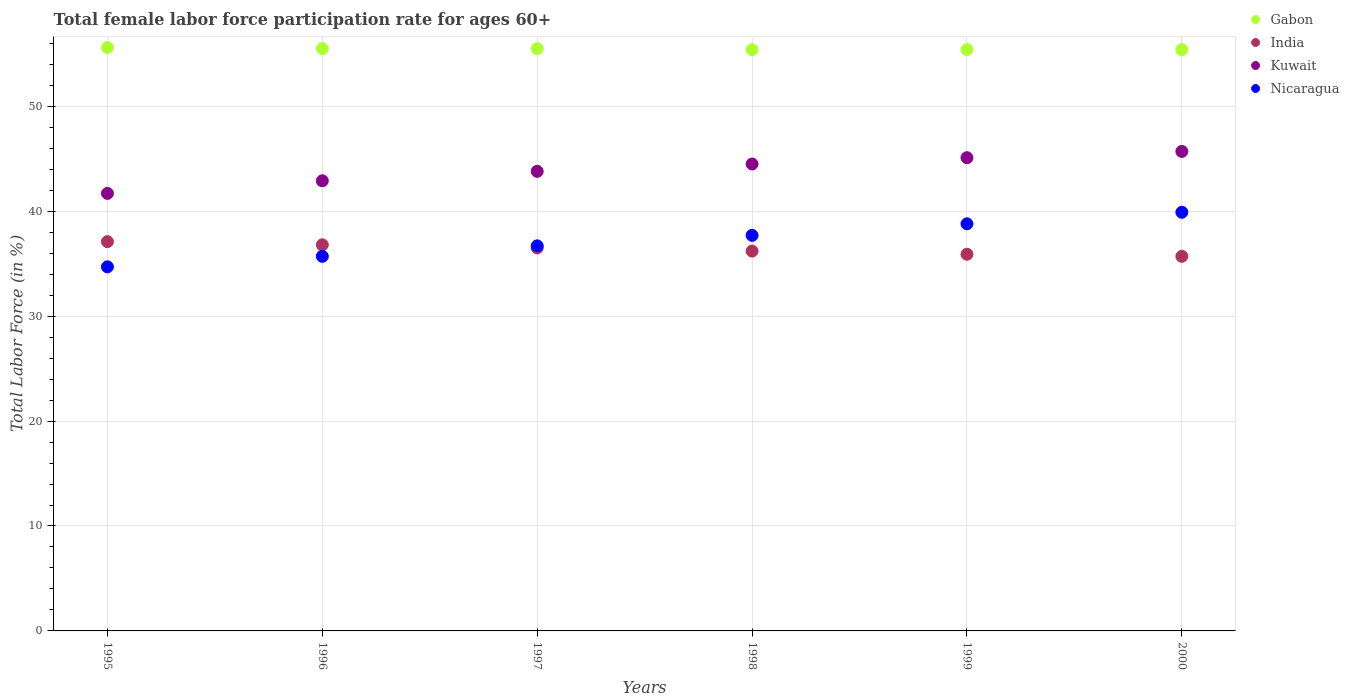How many different coloured dotlines are there?
Make the answer very short. 4. What is the female labor force participation rate in Gabon in 2000?
Your response must be concise. 55.4. Across all years, what is the maximum female labor force participation rate in Kuwait?
Offer a terse response. 45.7. Across all years, what is the minimum female labor force participation rate in Nicaragua?
Give a very brief answer. 34.7. In which year was the female labor force participation rate in Nicaragua minimum?
Make the answer very short. 1995. What is the total female labor force participation rate in Kuwait in the graph?
Offer a terse response. 263.7. What is the difference between the female labor force participation rate in Nicaragua in 1996 and that in 1998?
Offer a terse response. -2. What is the average female labor force participation rate in Kuwait per year?
Give a very brief answer. 43.95. In how many years, is the female labor force participation rate in Nicaragua greater than 20 %?
Your response must be concise. 6. What is the ratio of the female labor force participation rate in Nicaragua in 1995 to that in 1997?
Offer a terse response. 0.95. Is the female labor force participation rate in India in 1995 less than that in 1996?
Make the answer very short. No. Is the difference between the female labor force participation rate in Gabon in 1997 and 2000 greater than the difference between the female labor force participation rate in Nicaragua in 1997 and 2000?
Make the answer very short. Yes. What is the difference between the highest and the second highest female labor force participation rate in Kuwait?
Offer a terse response. 0.6. What is the difference between the highest and the lowest female labor force participation rate in Gabon?
Provide a short and direct response. 0.2. In how many years, is the female labor force participation rate in Kuwait greater than the average female labor force participation rate in Kuwait taken over all years?
Make the answer very short. 3. Is the sum of the female labor force participation rate in Kuwait in 1995 and 1997 greater than the maximum female labor force participation rate in Nicaragua across all years?
Keep it short and to the point. Yes. Is it the case that in every year, the sum of the female labor force participation rate in Kuwait and female labor force participation rate in Nicaragua  is greater than the sum of female labor force participation rate in India and female labor force participation rate in Gabon?
Your answer should be very brief. No. Is the female labor force participation rate in Gabon strictly less than the female labor force participation rate in Kuwait over the years?
Your response must be concise. No. How many years are there in the graph?
Offer a terse response. 6. Are the values on the major ticks of Y-axis written in scientific E-notation?
Your answer should be very brief. No. Does the graph contain any zero values?
Make the answer very short. No. Does the graph contain grids?
Provide a succinct answer. Yes. Where does the legend appear in the graph?
Keep it short and to the point. Top right. How many legend labels are there?
Keep it short and to the point. 4. How are the legend labels stacked?
Ensure brevity in your answer.  Vertical. What is the title of the graph?
Ensure brevity in your answer.  Total female labor force participation rate for ages 60+. What is the label or title of the X-axis?
Offer a very short reply. Years. What is the label or title of the Y-axis?
Ensure brevity in your answer.  Total Labor Force (in %). What is the Total Labor Force (in %) of Gabon in 1995?
Your answer should be compact. 55.6. What is the Total Labor Force (in %) in India in 1995?
Keep it short and to the point. 37.1. What is the Total Labor Force (in %) in Kuwait in 1995?
Offer a very short reply. 41.7. What is the Total Labor Force (in %) in Nicaragua in 1995?
Provide a short and direct response. 34.7. What is the Total Labor Force (in %) of Gabon in 1996?
Your response must be concise. 55.5. What is the Total Labor Force (in %) of India in 1996?
Give a very brief answer. 36.8. What is the Total Labor Force (in %) in Kuwait in 1996?
Offer a terse response. 42.9. What is the Total Labor Force (in %) of Nicaragua in 1996?
Make the answer very short. 35.7. What is the Total Labor Force (in %) in Gabon in 1997?
Your answer should be compact. 55.5. What is the Total Labor Force (in %) in India in 1997?
Provide a short and direct response. 36.5. What is the Total Labor Force (in %) of Kuwait in 1997?
Provide a short and direct response. 43.8. What is the Total Labor Force (in %) of Nicaragua in 1997?
Ensure brevity in your answer.  36.7. What is the Total Labor Force (in %) in Gabon in 1998?
Keep it short and to the point. 55.4. What is the Total Labor Force (in %) of India in 1998?
Make the answer very short. 36.2. What is the Total Labor Force (in %) of Kuwait in 1998?
Offer a terse response. 44.5. What is the Total Labor Force (in %) of Nicaragua in 1998?
Offer a very short reply. 37.7. What is the Total Labor Force (in %) of Gabon in 1999?
Offer a very short reply. 55.4. What is the Total Labor Force (in %) of India in 1999?
Ensure brevity in your answer.  35.9. What is the Total Labor Force (in %) of Kuwait in 1999?
Make the answer very short. 45.1. What is the Total Labor Force (in %) in Nicaragua in 1999?
Your response must be concise. 38.8. What is the Total Labor Force (in %) of Gabon in 2000?
Provide a short and direct response. 55.4. What is the Total Labor Force (in %) of India in 2000?
Your answer should be compact. 35.7. What is the Total Labor Force (in %) in Kuwait in 2000?
Ensure brevity in your answer.  45.7. What is the Total Labor Force (in %) in Nicaragua in 2000?
Provide a succinct answer. 39.9. Across all years, what is the maximum Total Labor Force (in %) of Gabon?
Offer a terse response. 55.6. Across all years, what is the maximum Total Labor Force (in %) in India?
Give a very brief answer. 37.1. Across all years, what is the maximum Total Labor Force (in %) of Kuwait?
Provide a succinct answer. 45.7. Across all years, what is the maximum Total Labor Force (in %) in Nicaragua?
Make the answer very short. 39.9. Across all years, what is the minimum Total Labor Force (in %) in Gabon?
Make the answer very short. 55.4. Across all years, what is the minimum Total Labor Force (in %) in India?
Ensure brevity in your answer.  35.7. Across all years, what is the minimum Total Labor Force (in %) of Kuwait?
Keep it short and to the point. 41.7. Across all years, what is the minimum Total Labor Force (in %) of Nicaragua?
Your response must be concise. 34.7. What is the total Total Labor Force (in %) of Gabon in the graph?
Provide a succinct answer. 332.8. What is the total Total Labor Force (in %) of India in the graph?
Your response must be concise. 218.2. What is the total Total Labor Force (in %) in Kuwait in the graph?
Offer a very short reply. 263.7. What is the total Total Labor Force (in %) of Nicaragua in the graph?
Provide a short and direct response. 223.5. What is the difference between the Total Labor Force (in %) of Kuwait in 1995 and that in 1996?
Provide a short and direct response. -1.2. What is the difference between the Total Labor Force (in %) of Gabon in 1995 and that in 1997?
Ensure brevity in your answer.  0.1. What is the difference between the Total Labor Force (in %) in Kuwait in 1995 and that in 1998?
Keep it short and to the point. -2.8. What is the difference between the Total Labor Force (in %) in Nicaragua in 1995 and that in 1998?
Offer a very short reply. -3. What is the difference between the Total Labor Force (in %) in India in 1995 and that in 2000?
Ensure brevity in your answer.  1.4. What is the difference between the Total Labor Force (in %) in Gabon in 1996 and that in 1997?
Ensure brevity in your answer.  0. What is the difference between the Total Labor Force (in %) of Kuwait in 1996 and that in 1997?
Provide a short and direct response. -0.9. What is the difference between the Total Labor Force (in %) of Nicaragua in 1996 and that in 1997?
Give a very brief answer. -1. What is the difference between the Total Labor Force (in %) of India in 1996 and that in 1998?
Your answer should be very brief. 0.6. What is the difference between the Total Labor Force (in %) of Nicaragua in 1996 and that in 1999?
Ensure brevity in your answer.  -3.1. What is the difference between the Total Labor Force (in %) in Gabon in 1996 and that in 2000?
Make the answer very short. 0.1. What is the difference between the Total Labor Force (in %) in Kuwait in 1996 and that in 2000?
Provide a succinct answer. -2.8. What is the difference between the Total Labor Force (in %) of Nicaragua in 1996 and that in 2000?
Give a very brief answer. -4.2. What is the difference between the Total Labor Force (in %) of Gabon in 1997 and that in 1998?
Provide a short and direct response. 0.1. What is the difference between the Total Labor Force (in %) in India in 1997 and that in 1998?
Provide a short and direct response. 0.3. What is the difference between the Total Labor Force (in %) in Nicaragua in 1997 and that in 1998?
Give a very brief answer. -1. What is the difference between the Total Labor Force (in %) in India in 1997 and that in 1999?
Make the answer very short. 0.6. What is the difference between the Total Labor Force (in %) of Kuwait in 1997 and that in 1999?
Offer a very short reply. -1.3. What is the difference between the Total Labor Force (in %) in Nicaragua in 1997 and that in 1999?
Your answer should be compact. -2.1. What is the difference between the Total Labor Force (in %) of Gabon in 1997 and that in 2000?
Make the answer very short. 0.1. What is the difference between the Total Labor Force (in %) of India in 1997 and that in 2000?
Offer a very short reply. 0.8. What is the difference between the Total Labor Force (in %) in Gabon in 1998 and that in 1999?
Provide a succinct answer. 0. What is the difference between the Total Labor Force (in %) in Kuwait in 1998 and that in 1999?
Offer a terse response. -0.6. What is the difference between the Total Labor Force (in %) of India in 1998 and that in 2000?
Your answer should be compact. 0.5. What is the difference between the Total Labor Force (in %) of Gabon in 1999 and that in 2000?
Offer a very short reply. 0. What is the difference between the Total Labor Force (in %) of Nicaragua in 1999 and that in 2000?
Your answer should be compact. -1.1. What is the difference between the Total Labor Force (in %) in Gabon in 1995 and the Total Labor Force (in %) in India in 1996?
Give a very brief answer. 18.8. What is the difference between the Total Labor Force (in %) of Gabon in 1995 and the Total Labor Force (in %) of Kuwait in 1996?
Give a very brief answer. 12.7. What is the difference between the Total Labor Force (in %) in Gabon in 1995 and the Total Labor Force (in %) in Nicaragua in 1996?
Offer a terse response. 19.9. What is the difference between the Total Labor Force (in %) in Gabon in 1995 and the Total Labor Force (in %) in India in 1997?
Your answer should be very brief. 19.1. What is the difference between the Total Labor Force (in %) in Gabon in 1995 and the Total Labor Force (in %) in Kuwait in 1997?
Make the answer very short. 11.8. What is the difference between the Total Labor Force (in %) in India in 1995 and the Total Labor Force (in %) in Kuwait in 1997?
Your answer should be very brief. -6.7. What is the difference between the Total Labor Force (in %) of India in 1995 and the Total Labor Force (in %) of Nicaragua in 1997?
Make the answer very short. 0.4. What is the difference between the Total Labor Force (in %) of Gabon in 1995 and the Total Labor Force (in %) of India in 1998?
Your response must be concise. 19.4. What is the difference between the Total Labor Force (in %) in Gabon in 1995 and the Total Labor Force (in %) in Nicaragua in 1998?
Your response must be concise. 17.9. What is the difference between the Total Labor Force (in %) in India in 1995 and the Total Labor Force (in %) in Nicaragua in 1998?
Your response must be concise. -0.6. What is the difference between the Total Labor Force (in %) in Gabon in 1995 and the Total Labor Force (in %) in India in 1999?
Keep it short and to the point. 19.7. What is the difference between the Total Labor Force (in %) of Gabon in 1995 and the Total Labor Force (in %) of Nicaragua in 1999?
Ensure brevity in your answer.  16.8. What is the difference between the Total Labor Force (in %) of India in 1995 and the Total Labor Force (in %) of Kuwait in 1999?
Your response must be concise. -8. What is the difference between the Total Labor Force (in %) of Kuwait in 1995 and the Total Labor Force (in %) of Nicaragua in 1999?
Ensure brevity in your answer.  2.9. What is the difference between the Total Labor Force (in %) in Gabon in 1995 and the Total Labor Force (in %) in India in 2000?
Your answer should be compact. 19.9. What is the difference between the Total Labor Force (in %) of Gabon in 1995 and the Total Labor Force (in %) of Kuwait in 2000?
Provide a succinct answer. 9.9. What is the difference between the Total Labor Force (in %) of Gabon in 1996 and the Total Labor Force (in %) of Kuwait in 1997?
Keep it short and to the point. 11.7. What is the difference between the Total Labor Force (in %) of India in 1996 and the Total Labor Force (in %) of Kuwait in 1997?
Your answer should be very brief. -7. What is the difference between the Total Labor Force (in %) in Kuwait in 1996 and the Total Labor Force (in %) in Nicaragua in 1997?
Give a very brief answer. 6.2. What is the difference between the Total Labor Force (in %) in Gabon in 1996 and the Total Labor Force (in %) in India in 1998?
Your answer should be compact. 19.3. What is the difference between the Total Labor Force (in %) of Gabon in 1996 and the Total Labor Force (in %) of Kuwait in 1998?
Make the answer very short. 11. What is the difference between the Total Labor Force (in %) in Gabon in 1996 and the Total Labor Force (in %) in Nicaragua in 1998?
Provide a short and direct response. 17.8. What is the difference between the Total Labor Force (in %) in India in 1996 and the Total Labor Force (in %) in Kuwait in 1998?
Your response must be concise. -7.7. What is the difference between the Total Labor Force (in %) of India in 1996 and the Total Labor Force (in %) of Nicaragua in 1998?
Ensure brevity in your answer.  -0.9. What is the difference between the Total Labor Force (in %) in Gabon in 1996 and the Total Labor Force (in %) in India in 1999?
Keep it short and to the point. 19.6. What is the difference between the Total Labor Force (in %) in Gabon in 1996 and the Total Labor Force (in %) in Nicaragua in 1999?
Give a very brief answer. 16.7. What is the difference between the Total Labor Force (in %) of India in 1996 and the Total Labor Force (in %) of Nicaragua in 1999?
Your answer should be compact. -2. What is the difference between the Total Labor Force (in %) in Kuwait in 1996 and the Total Labor Force (in %) in Nicaragua in 1999?
Keep it short and to the point. 4.1. What is the difference between the Total Labor Force (in %) of Gabon in 1996 and the Total Labor Force (in %) of India in 2000?
Give a very brief answer. 19.8. What is the difference between the Total Labor Force (in %) in Gabon in 1996 and the Total Labor Force (in %) in Kuwait in 2000?
Give a very brief answer. 9.8. What is the difference between the Total Labor Force (in %) in India in 1996 and the Total Labor Force (in %) in Nicaragua in 2000?
Provide a succinct answer. -3.1. What is the difference between the Total Labor Force (in %) of Gabon in 1997 and the Total Labor Force (in %) of India in 1998?
Give a very brief answer. 19.3. What is the difference between the Total Labor Force (in %) in Gabon in 1997 and the Total Labor Force (in %) in Nicaragua in 1998?
Your answer should be very brief. 17.8. What is the difference between the Total Labor Force (in %) in India in 1997 and the Total Labor Force (in %) in Kuwait in 1998?
Your answer should be very brief. -8. What is the difference between the Total Labor Force (in %) in Kuwait in 1997 and the Total Labor Force (in %) in Nicaragua in 1998?
Make the answer very short. 6.1. What is the difference between the Total Labor Force (in %) of Gabon in 1997 and the Total Labor Force (in %) of India in 1999?
Keep it short and to the point. 19.6. What is the difference between the Total Labor Force (in %) of Gabon in 1997 and the Total Labor Force (in %) of Nicaragua in 1999?
Your answer should be very brief. 16.7. What is the difference between the Total Labor Force (in %) of India in 1997 and the Total Labor Force (in %) of Nicaragua in 1999?
Offer a terse response. -2.3. What is the difference between the Total Labor Force (in %) of Gabon in 1997 and the Total Labor Force (in %) of India in 2000?
Offer a very short reply. 19.8. What is the difference between the Total Labor Force (in %) of Gabon in 1997 and the Total Labor Force (in %) of Kuwait in 2000?
Give a very brief answer. 9.8. What is the difference between the Total Labor Force (in %) in India in 1997 and the Total Labor Force (in %) in Kuwait in 2000?
Keep it short and to the point. -9.2. What is the difference between the Total Labor Force (in %) in India in 1997 and the Total Labor Force (in %) in Nicaragua in 2000?
Ensure brevity in your answer.  -3.4. What is the difference between the Total Labor Force (in %) in Gabon in 1998 and the Total Labor Force (in %) in Kuwait in 1999?
Your answer should be compact. 10.3. What is the difference between the Total Labor Force (in %) in Gabon in 1998 and the Total Labor Force (in %) in Nicaragua in 1999?
Offer a terse response. 16.6. What is the difference between the Total Labor Force (in %) of India in 1998 and the Total Labor Force (in %) of Kuwait in 1999?
Keep it short and to the point. -8.9. What is the difference between the Total Labor Force (in %) of India in 1998 and the Total Labor Force (in %) of Nicaragua in 1999?
Make the answer very short. -2.6. What is the difference between the Total Labor Force (in %) in Gabon in 1998 and the Total Labor Force (in %) in Kuwait in 2000?
Ensure brevity in your answer.  9.7. What is the difference between the Total Labor Force (in %) in Gabon in 1998 and the Total Labor Force (in %) in Nicaragua in 2000?
Offer a very short reply. 15.5. What is the difference between the Total Labor Force (in %) of Gabon in 1999 and the Total Labor Force (in %) of Nicaragua in 2000?
Keep it short and to the point. 15.5. What is the difference between the Total Labor Force (in %) in India in 1999 and the Total Labor Force (in %) in Kuwait in 2000?
Offer a terse response. -9.8. What is the average Total Labor Force (in %) of Gabon per year?
Offer a very short reply. 55.47. What is the average Total Labor Force (in %) of India per year?
Your response must be concise. 36.37. What is the average Total Labor Force (in %) of Kuwait per year?
Your answer should be compact. 43.95. What is the average Total Labor Force (in %) of Nicaragua per year?
Make the answer very short. 37.25. In the year 1995, what is the difference between the Total Labor Force (in %) in Gabon and Total Labor Force (in %) in India?
Keep it short and to the point. 18.5. In the year 1995, what is the difference between the Total Labor Force (in %) of Gabon and Total Labor Force (in %) of Kuwait?
Make the answer very short. 13.9. In the year 1995, what is the difference between the Total Labor Force (in %) in Gabon and Total Labor Force (in %) in Nicaragua?
Provide a succinct answer. 20.9. In the year 1995, what is the difference between the Total Labor Force (in %) of India and Total Labor Force (in %) of Nicaragua?
Make the answer very short. 2.4. In the year 1995, what is the difference between the Total Labor Force (in %) of Kuwait and Total Labor Force (in %) of Nicaragua?
Provide a succinct answer. 7. In the year 1996, what is the difference between the Total Labor Force (in %) of Gabon and Total Labor Force (in %) of Nicaragua?
Offer a very short reply. 19.8. In the year 1996, what is the difference between the Total Labor Force (in %) of India and Total Labor Force (in %) of Kuwait?
Your response must be concise. -6.1. In the year 1996, what is the difference between the Total Labor Force (in %) in India and Total Labor Force (in %) in Nicaragua?
Keep it short and to the point. 1.1. In the year 1996, what is the difference between the Total Labor Force (in %) of Kuwait and Total Labor Force (in %) of Nicaragua?
Give a very brief answer. 7.2. In the year 1997, what is the difference between the Total Labor Force (in %) of Gabon and Total Labor Force (in %) of Kuwait?
Give a very brief answer. 11.7. In the year 1997, what is the difference between the Total Labor Force (in %) of Gabon and Total Labor Force (in %) of Nicaragua?
Your answer should be compact. 18.8. In the year 1997, what is the difference between the Total Labor Force (in %) in Kuwait and Total Labor Force (in %) in Nicaragua?
Make the answer very short. 7.1. In the year 1998, what is the difference between the Total Labor Force (in %) of Gabon and Total Labor Force (in %) of Kuwait?
Your answer should be compact. 10.9. In the year 1998, what is the difference between the Total Labor Force (in %) of Gabon and Total Labor Force (in %) of Nicaragua?
Ensure brevity in your answer.  17.7. In the year 1999, what is the difference between the Total Labor Force (in %) of Gabon and Total Labor Force (in %) of India?
Your response must be concise. 19.5. In the year 1999, what is the difference between the Total Labor Force (in %) in Kuwait and Total Labor Force (in %) in Nicaragua?
Make the answer very short. 6.3. In the year 2000, what is the difference between the Total Labor Force (in %) of Gabon and Total Labor Force (in %) of India?
Offer a terse response. 19.7. In the year 2000, what is the difference between the Total Labor Force (in %) in Kuwait and Total Labor Force (in %) in Nicaragua?
Make the answer very short. 5.8. What is the ratio of the Total Labor Force (in %) of India in 1995 to that in 1996?
Keep it short and to the point. 1.01. What is the ratio of the Total Labor Force (in %) of Kuwait in 1995 to that in 1996?
Ensure brevity in your answer.  0.97. What is the ratio of the Total Labor Force (in %) in Gabon in 1995 to that in 1997?
Offer a terse response. 1. What is the ratio of the Total Labor Force (in %) of India in 1995 to that in 1997?
Offer a terse response. 1.02. What is the ratio of the Total Labor Force (in %) in Kuwait in 1995 to that in 1997?
Provide a succinct answer. 0.95. What is the ratio of the Total Labor Force (in %) of Nicaragua in 1995 to that in 1997?
Provide a succinct answer. 0.95. What is the ratio of the Total Labor Force (in %) in India in 1995 to that in 1998?
Your response must be concise. 1.02. What is the ratio of the Total Labor Force (in %) of Kuwait in 1995 to that in 1998?
Make the answer very short. 0.94. What is the ratio of the Total Labor Force (in %) in Nicaragua in 1995 to that in 1998?
Offer a very short reply. 0.92. What is the ratio of the Total Labor Force (in %) of Gabon in 1995 to that in 1999?
Offer a terse response. 1. What is the ratio of the Total Labor Force (in %) in India in 1995 to that in 1999?
Keep it short and to the point. 1.03. What is the ratio of the Total Labor Force (in %) of Kuwait in 1995 to that in 1999?
Your answer should be compact. 0.92. What is the ratio of the Total Labor Force (in %) of Nicaragua in 1995 to that in 1999?
Provide a short and direct response. 0.89. What is the ratio of the Total Labor Force (in %) of Gabon in 1995 to that in 2000?
Ensure brevity in your answer.  1. What is the ratio of the Total Labor Force (in %) in India in 1995 to that in 2000?
Ensure brevity in your answer.  1.04. What is the ratio of the Total Labor Force (in %) in Kuwait in 1995 to that in 2000?
Ensure brevity in your answer.  0.91. What is the ratio of the Total Labor Force (in %) of Nicaragua in 1995 to that in 2000?
Make the answer very short. 0.87. What is the ratio of the Total Labor Force (in %) in India in 1996 to that in 1997?
Offer a very short reply. 1.01. What is the ratio of the Total Labor Force (in %) in Kuwait in 1996 to that in 1997?
Ensure brevity in your answer.  0.98. What is the ratio of the Total Labor Force (in %) of Nicaragua in 1996 to that in 1997?
Your answer should be very brief. 0.97. What is the ratio of the Total Labor Force (in %) of India in 1996 to that in 1998?
Your answer should be very brief. 1.02. What is the ratio of the Total Labor Force (in %) of Kuwait in 1996 to that in 1998?
Offer a very short reply. 0.96. What is the ratio of the Total Labor Force (in %) of Nicaragua in 1996 to that in 1998?
Make the answer very short. 0.95. What is the ratio of the Total Labor Force (in %) of Gabon in 1996 to that in 1999?
Offer a very short reply. 1. What is the ratio of the Total Labor Force (in %) of India in 1996 to that in 1999?
Provide a succinct answer. 1.03. What is the ratio of the Total Labor Force (in %) in Kuwait in 1996 to that in 1999?
Provide a succinct answer. 0.95. What is the ratio of the Total Labor Force (in %) of Nicaragua in 1996 to that in 1999?
Keep it short and to the point. 0.92. What is the ratio of the Total Labor Force (in %) in India in 1996 to that in 2000?
Provide a succinct answer. 1.03. What is the ratio of the Total Labor Force (in %) in Kuwait in 1996 to that in 2000?
Make the answer very short. 0.94. What is the ratio of the Total Labor Force (in %) of Nicaragua in 1996 to that in 2000?
Your answer should be very brief. 0.89. What is the ratio of the Total Labor Force (in %) of India in 1997 to that in 1998?
Your answer should be very brief. 1.01. What is the ratio of the Total Labor Force (in %) of Kuwait in 1997 to that in 1998?
Give a very brief answer. 0.98. What is the ratio of the Total Labor Force (in %) in Nicaragua in 1997 to that in 1998?
Give a very brief answer. 0.97. What is the ratio of the Total Labor Force (in %) of India in 1997 to that in 1999?
Offer a very short reply. 1.02. What is the ratio of the Total Labor Force (in %) of Kuwait in 1997 to that in 1999?
Provide a succinct answer. 0.97. What is the ratio of the Total Labor Force (in %) of Nicaragua in 1997 to that in 1999?
Provide a short and direct response. 0.95. What is the ratio of the Total Labor Force (in %) of India in 1997 to that in 2000?
Provide a short and direct response. 1.02. What is the ratio of the Total Labor Force (in %) in Kuwait in 1997 to that in 2000?
Give a very brief answer. 0.96. What is the ratio of the Total Labor Force (in %) of Nicaragua in 1997 to that in 2000?
Provide a short and direct response. 0.92. What is the ratio of the Total Labor Force (in %) of India in 1998 to that in 1999?
Your answer should be very brief. 1.01. What is the ratio of the Total Labor Force (in %) in Kuwait in 1998 to that in 1999?
Your answer should be compact. 0.99. What is the ratio of the Total Labor Force (in %) in Nicaragua in 1998 to that in 1999?
Your answer should be very brief. 0.97. What is the ratio of the Total Labor Force (in %) in India in 1998 to that in 2000?
Your response must be concise. 1.01. What is the ratio of the Total Labor Force (in %) in Kuwait in 1998 to that in 2000?
Offer a terse response. 0.97. What is the ratio of the Total Labor Force (in %) of Nicaragua in 1998 to that in 2000?
Your answer should be compact. 0.94. What is the ratio of the Total Labor Force (in %) in Gabon in 1999 to that in 2000?
Make the answer very short. 1. What is the ratio of the Total Labor Force (in %) in India in 1999 to that in 2000?
Your answer should be compact. 1.01. What is the ratio of the Total Labor Force (in %) in Kuwait in 1999 to that in 2000?
Make the answer very short. 0.99. What is the ratio of the Total Labor Force (in %) in Nicaragua in 1999 to that in 2000?
Your answer should be compact. 0.97. What is the difference between the highest and the second highest Total Labor Force (in %) in Nicaragua?
Give a very brief answer. 1.1. What is the difference between the highest and the lowest Total Labor Force (in %) of Gabon?
Make the answer very short. 0.2. What is the difference between the highest and the lowest Total Labor Force (in %) in Kuwait?
Provide a short and direct response. 4. 